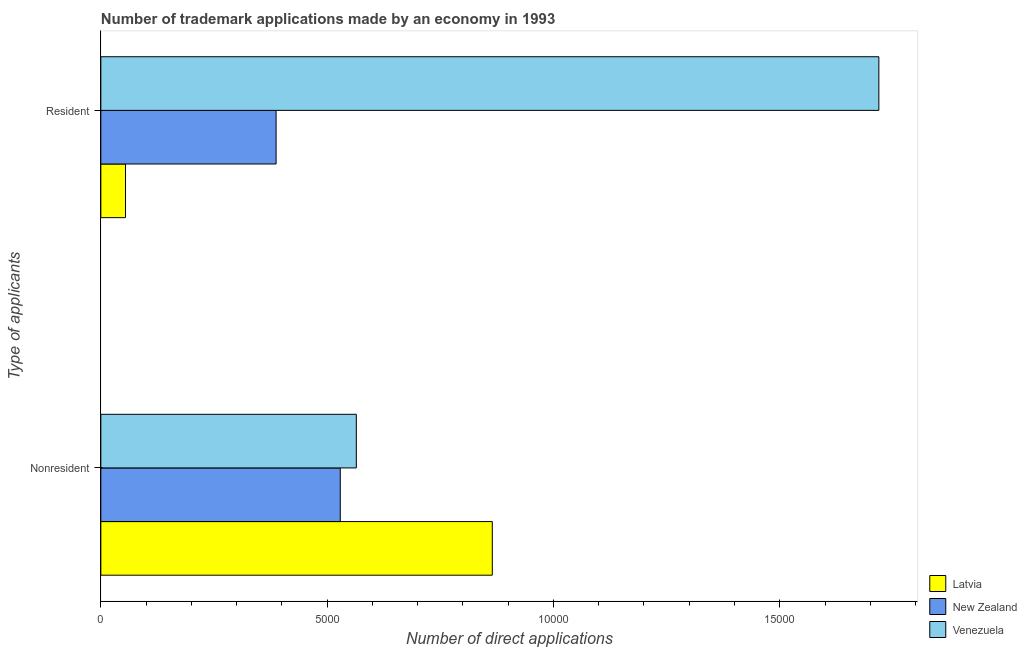How many groups of bars are there?
Make the answer very short. 2. How many bars are there on the 2nd tick from the top?
Provide a succinct answer. 3. How many bars are there on the 2nd tick from the bottom?
Offer a very short reply. 3. What is the label of the 2nd group of bars from the top?
Your response must be concise. Nonresident. What is the number of trademark applications made by non residents in Latvia?
Keep it short and to the point. 8649. Across all countries, what is the maximum number of trademark applications made by residents?
Make the answer very short. 1.72e+04. Across all countries, what is the minimum number of trademark applications made by non residents?
Provide a succinct answer. 5290. In which country was the number of trademark applications made by non residents maximum?
Provide a succinct answer. Latvia. In which country was the number of trademark applications made by residents minimum?
Make the answer very short. Latvia. What is the total number of trademark applications made by residents in the graph?
Provide a short and direct response. 2.16e+04. What is the difference between the number of trademark applications made by residents in New Zealand and that in Venezuela?
Make the answer very short. -1.33e+04. What is the difference between the number of trademark applications made by residents in Latvia and the number of trademark applications made by non residents in Venezuela?
Ensure brevity in your answer.  -5100. What is the average number of trademark applications made by non residents per country?
Your response must be concise. 6528. What is the difference between the number of trademark applications made by residents and number of trademark applications made by non residents in Latvia?
Offer a terse response. -8104. What is the ratio of the number of trademark applications made by residents in New Zealand to that in Latvia?
Your answer should be very brief. 7.1. In how many countries, is the number of trademark applications made by non residents greater than the average number of trademark applications made by non residents taken over all countries?
Give a very brief answer. 1. What does the 3rd bar from the top in Nonresident represents?
Give a very brief answer. Latvia. What does the 3rd bar from the bottom in Resident represents?
Your answer should be very brief. Venezuela. What is the difference between two consecutive major ticks on the X-axis?
Your response must be concise. 5000. Are the values on the major ticks of X-axis written in scientific E-notation?
Your response must be concise. No. Does the graph contain any zero values?
Provide a succinct answer. No. Does the graph contain grids?
Your answer should be very brief. No. How are the legend labels stacked?
Ensure brevity in your answer.  Vertical. What is the title of the graph?
Your response must be concise. Number of trademark applications made by an economy in 1993. Does "Samoa" appear as one of the legend labels in the graph?
Offer a terse response. No. What is the label or title of the X-axis?
Your answer should be very brief. Number of direct applications. What is the label or title of the Y-axis?
Your answer should be compact. Type of applicants. What is the Number of direct applications of Latvia in Nonresident?
Keep it short and to the point. 8649. What is the Number of direct applications of New Zealand in Nonresident?
Your answer should be compact. 5290. What is the Number of direct applications of Venezuela in Nonresident?
Make the answer very short. 5645. What is the Number of direct applications of Latvia in Resident?
Give a very brief answer. 545. What is the Number of direct applications in New Zealand in Resident?
Your answer should be very brief. 3872. What is the Number of direct applications of Venezuela in Resident?
Keep it short and to the point. 1.72e+04. Across all Type of applicants, what is the maximum Number of direct applications of Latvia?
Your answer should be very brief. 8649. Across all Type of applicants, what is the maximum Number of direct applications of New Zealand?
Keep it short and to the point. 5290. Across all Type of applicants, what is the maximum Number of direct applications in Venezuela?
Your answer should be very brief. 1.72e+04. Across all Type of applicants, what is the minimum Number of direct applications in Latvia?
Ensure brevity in your answer.  545. Across all Type of applicants, what is the minimum Number of direct applications in New Zealand?
Ensure brevity in your answer.  3872. Across all Type of applicants, what is the minimum Number of direct applications of Venezuela?
Your answer should be very brief. 5645. What is the total Number of direct applications of Latvia in the graph?
Keep it short and to the point. 9194. What is the total Number of direct applications in New Zealand in the graph?
Ensure brevity in your answer.  9162. What is the total Number of direct applications of Venezuela in the graph?
Your answer should be compact. 2.28e+04. What is the difference between the Number of direct applications of Latvia in Nonresident and that in Resident?
Offer a terse response. 8104. What is the difference between the Number of direct applications in New Zealand in Nonresident and that in Resident?
Keep it short and to the point. 1418. What is the difference between the Number of direct applications of Venezuela in Nonresident and that in Resident?
Offer a very short reply. -1.15e+04. What is the difference between the Number of direct applications of Latvia in Nonresident and the Number of direct applications of New Zealand in Resident?
Ensure brevity in your answer.  4777. What is the difference between the Number of direct applications in Latvia in Nonresident and the Number of direct applications in Venezuela in Resident?
Your response must be concise. -8541. What is the difference between the Number of direct applications of New Zealand in Nonresident and the Number of direct applications of Venezuela in Resident?
Offer a terse response. -1.19e+04. What is the average Number of direct applications in Latvia per Type of applicants?
Give a very brief answer. 4597. What is the average Number of direct applications of New Zealand per Type of applicants?
Offer a very short reply. 4581. What is the average Number of direct applications of Venezuela per Type of applicants?
Make the answer very short. 1.14e+04. What is the difference between the Number of direct applications in Latvia and Number of direct applications in New Zealand in Nonresident?
Keep it short and to the point. 3359. What is the difference between the Number of direct applications of Latvia and Number of direct applications of Venezuela in Nonresident?
Provide a succinct answer. 3004. What is the difference between the Number of direct applications in New Zealand and Number of direct applications in Venezuela in Nonresident?
Give a very brief answer. -355. What is the difference between the Number of direct applications in Latvia and Number of direct applications in New Zealand in Resident?
Keep it short and to the point. -3327. What is the difference between the Number of direct applications of Latvia and Number of direct applications of Venezuela in Resident?
Keep it short and to the point. -1.66e+04. What is the difference between the Number of direct applications in New Zealand and Number of direct applications in Venezuela in Resident?
Provide a short and direct response. -1.33e+04. What is the ratio of the Number of direct applications of Latvia in Nonresident to that in Resident?
Provide a succinct answer. 15.87. What is the ratio of the Number of direct applications of New Zealand in Nonresident to that in Resident?
Ensure brevity in your answer.  1.37. What is the ratio of the Number of direct applications of Venezuela in Nonresident to that in Resident?
Your answer should be very brief. 0.33. What is the difference between the highest and the second highest Number of direct applications in Latvia?
Offer a terse response. 8104. What is the difference between the highest and the second highest Number of direct applications in New Zealand?
Your response must be concise. 1418. What is the difference between the highest and the second highest Number of direct applications of Venezuela?
Make the answer very short. 1.15e+04. What is the difference between the highest and the lowest Number of direct applications in Latvia?
Give a very brief answer. 8104. What is the difference between the highest and the lowest Number of direct applications of New Zealand?
Give a very brief answer. 1418. What is the difference between the highest and the lowest Number of direct applications of Venezuela?
Offer a very short reply. 1.15e+04. 